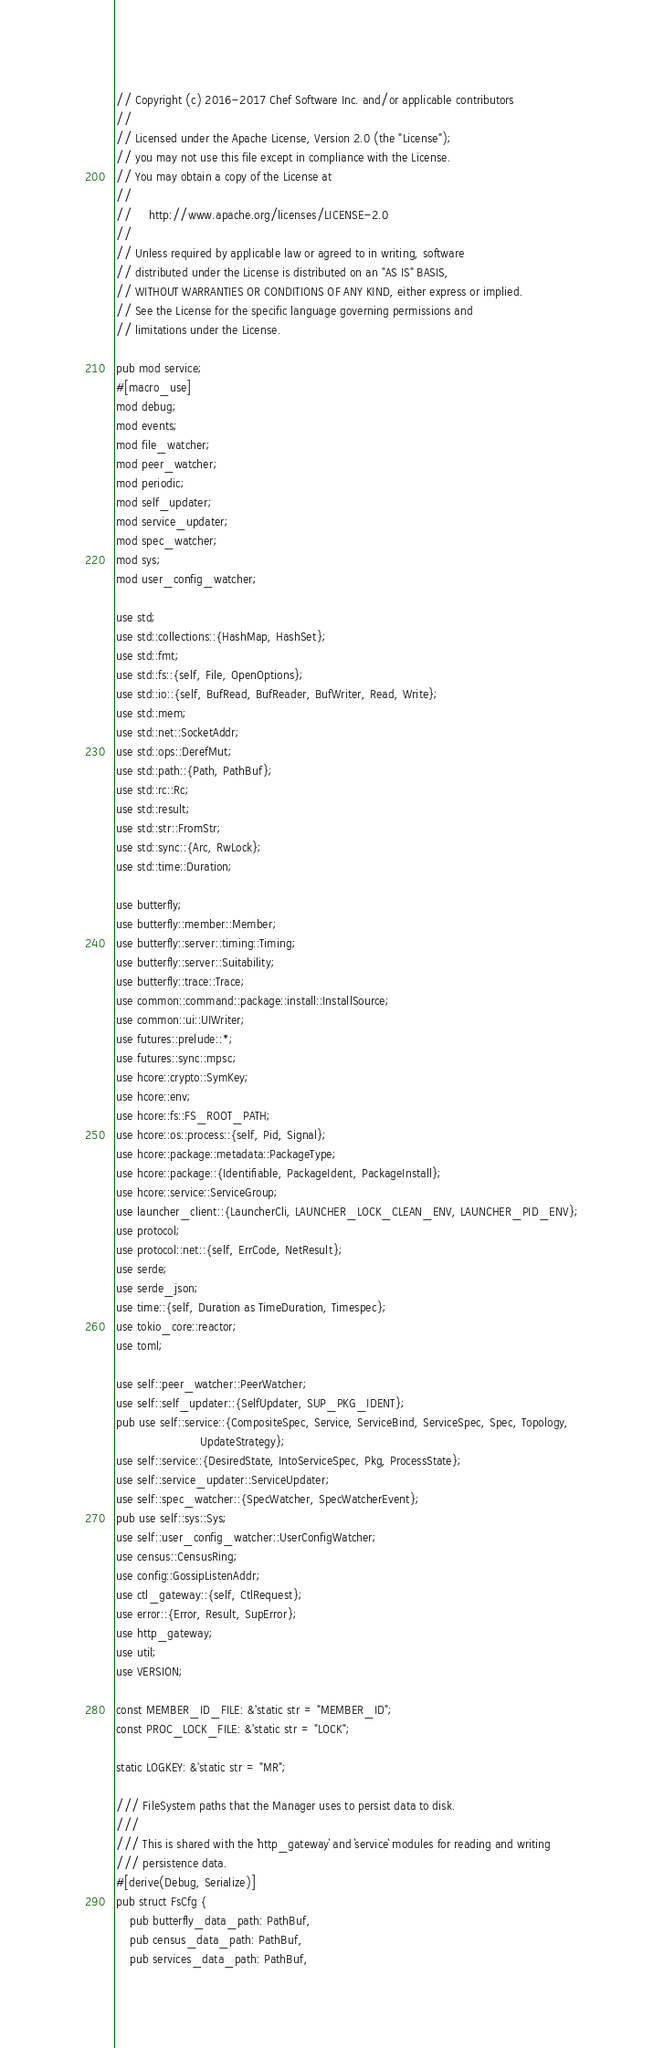Convert code to text. <code><loc_0><loc_0><loc_500><loc_500><_Rust_>// Copyright (c) 2016-2017 Chef Software Inc. and/or applicable contributors
//
// Licensed under the Apache License, Version 2.0 (the "License");
// you may not use this file except in compliance with the License.
// You may obtain a copy of the License at
//
//     http://www.apache.org/licenses/LICENSE-2.0
//
// Unless required by applicable law or agreed to in writing, software
// distributed under the License is distributed on an "AS IS" BASIS,
// WITHOUT WARRANTIES OR CONDITIONS OF ANY KIND, either express or implied.
// See the License for the specific language governing permissions and
// limitations under the License.

pub mod service;
#[macro_use]
mod debug;
mod events;
mod file_watcher;
mod peer_watcher;
mod periodic;
mod self_updater;
mod service_updater;
mod spec_watcher;
mod sys;
mod user_config_watcher;

use std;
use std::collections::{HashMap, HashSet};
use std::fmt;
use std::fs::{self, File, OpenOptions};
use std::io::{self, BufRead, BufReader, BufWriter, Read, Write};
use std::mem;
use std::net::SocketAddr;
use std::ops::DerefMut;
use std::path::{Path, PathBuf};
use std::rc::Rc;
use std::result;
use std::str::FromStr;
use std::sync::{Arc, RwLock};
use std::time::Duration;

use butterfly;
use butterfly::member::Member;
use butterfly::server::timing::Timing;
use butterfly::server::Suitability;
use butterfly::trace::Trace;
use common::command::package::install::InstallSource;
use common::ui::UIWriter;
use futures::prelude::*;
use futures::sync::mpsc;
use hcore::crypto::SymKey;
use hcore::env;
use hcore::fs::FS_ROOT_PATH;
use hcore::os::process::{self, Pid, Signal};
use hcore::package::metadata::PackageType;
use hcore::package::{Identifiable, PackageIdent, PackageInstall};
use hcore::service::ServiceGroup;
use launcher_client::{LauncherCli, LAUNCHER_LOCK_CLEAN_ENV, LAUNCHER_PID_ENV};
use protocol;
use protocol::net::{self, ErrCode, NetResult};
use serde;
use serde_json;
use time::{self, Duration as TimeDuration, Timespec};
use tokio_core::reactor;
use toml;

use self::peer_watcher::PeerWatcher;
use self::self_updater::{SelfUpdater, SUP_PKG_IDENT};
pub use self::service::{CompositeSpec, Service, ServiceBind, ServiceSpec, Spec, Topology,
                        UpdateStrategy};
use self::service::{DesiredState, IntoServiceSpec, Pkg, ProcessState};
use self::service_updater::ServiceUpdater;
use self::spec_watcher::{SpecWatcher, SpecWatcherEvent};
pub use self::sys::Sys;
use self::user_config_watcher::UserConfigWatcher;
use census::CensusRing;
use config::GossipListenAddr;
use ctl_gateway::{self, CtlRequest};
use error::{Error, Result, SupError};
use http_gateway;
use util;
use VERSION;

const MEMBER_ID_FILE: &'static str = "MEMBER_ID";
const PROC_LOCK_FILE: &'static str = "LOCK";

static LOGKEY: &'static str = "MR";

/// FileSystem paths that the Manager uses to persist data to disk.
///
/// This is shared with the `http_gateway` and `service` modules for reading and writing
/// persistence data.
#[derive(Debug, Serialize)]
pub struct FsCfg {
    pub butterfly_data_path: PathBuf,
    pub census_data_path: PathBuf,
    pub services_data_path: PathBuf,</code> 